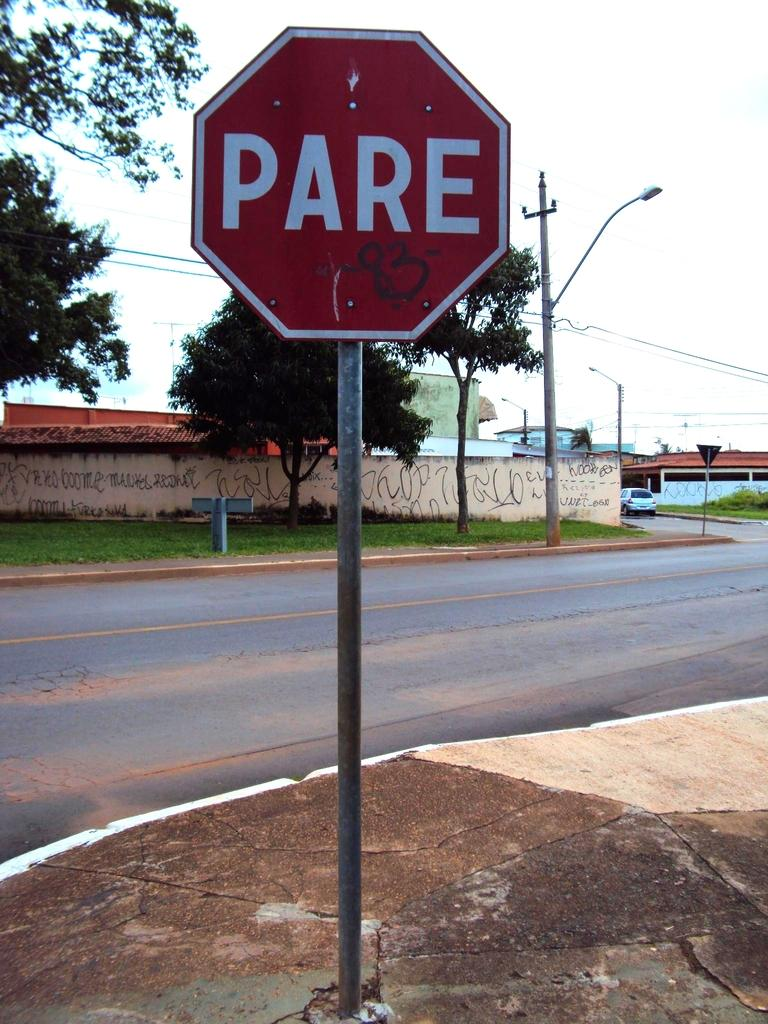<image>
Create a compact narrative representing the image presented. A red sign that says Pare on it. 